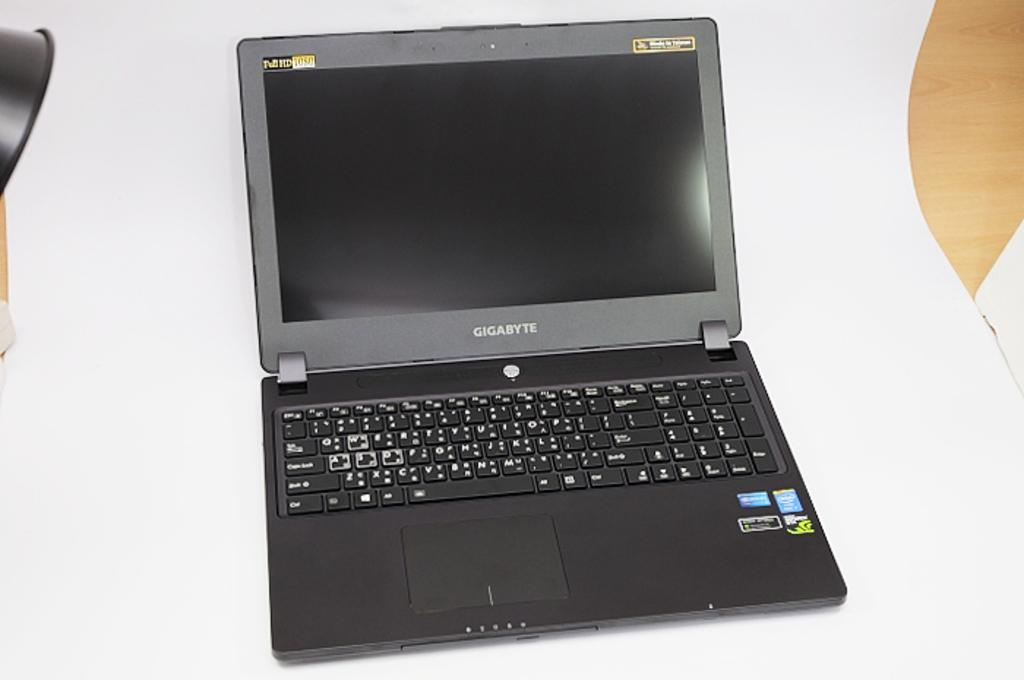<image>
Render a clear and concise summary of the photo. An open laptop computer has Gigabyte in print below the screen. 